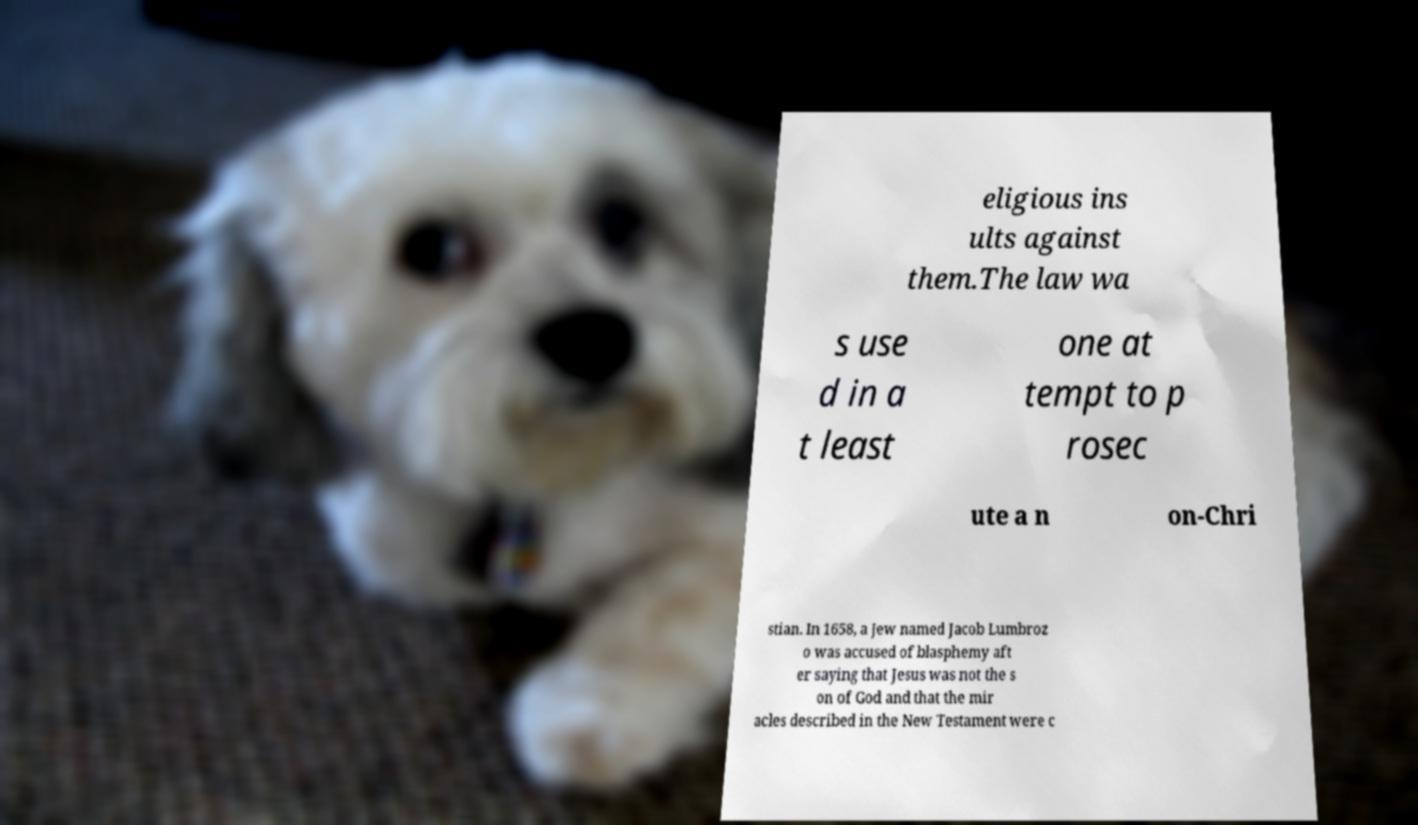Could you assist in decoding the text presented in this image and type it out clearly? eligious ins ults against them.The law wa s use d in a t least one at tempt to p rosec ute a n on-Chri stian. In 1658, a Jew named Jacob Lumbroz o was accused of blasphemy aft er saying that Jesus was not the s on of God and that the mir acles described in the New Testament were c 